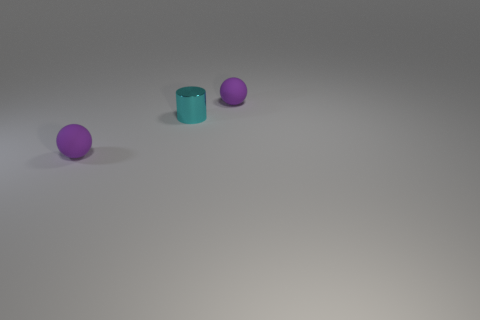Add 2 tiny matte spheres. How many objects exist? 5 Subtract all spheres. How many objects are left? 1 Subtract 0 green cylinders. How many objects are left? 3 Subtract all small purple objects. Subtract all tiny cyan metallic objects. How many objects are left? 0 Add 1 purple objects. How many purple objects are left? 3 Add 2 large yellow matte objects. How many large yellow matte objects exist? 2 